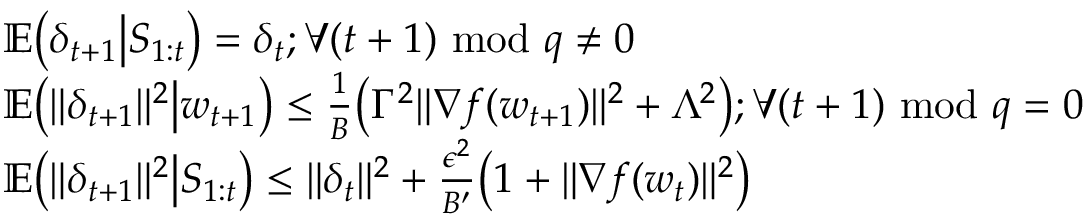Convert formula to latex. <formula><loc_0><loc_0><loc_500><loc_500>\begin{array} { r l } & { \mathbb { E } \Big ( \delta _ { t + 1 } \Big | S _ { 1 \colon t } \Big ) = \delta _ { t } ; \forall ( t + 1 ) m o d q \ne 0 } \\ & { \mathbb { E } \Big ( \| \delta _ { t + 1 } \| ^ { 2 } \Big | w _ { t + 1 } \Big ) \leq \frac { 1 } { B } \Big ( \Gamma ^ { 2 } \| \nabla f ( w _ { t + 1 } ) \| ^ { 2 } + \Lambda ^ { 2 } \Big ) ; \forall ( t + 1 ) m o d q = 0 } \\ & { \mathbb { E } \Big ( \| \delta _ { t + 1 } \| ^ { 2 } \Big | S _ { 1 \colon t } \Big ) \leq \| \delta _ { t } \| ^ { 2 } + \frac { \epsilon ^ { 2 } } { B ^ { \prime } } \Big ( 1 + \| \nabla f ( w _ { t } ) \| ^ { 2 } \Big ) } \end{array}</formula> 